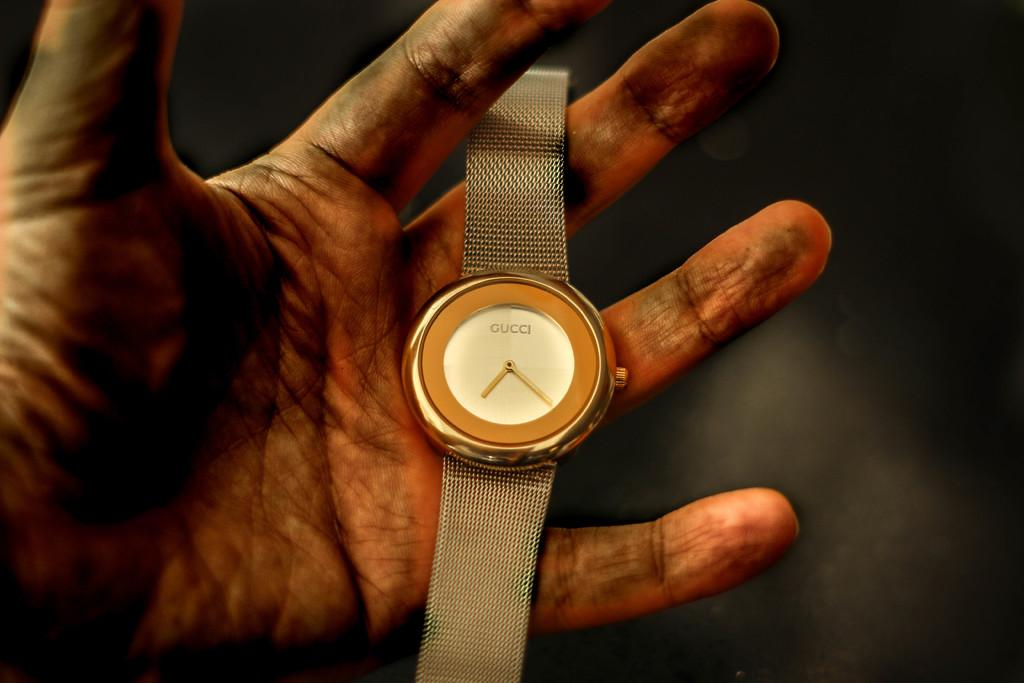Provide a one-sentence caption for the provided image. The Gucci watch is setting in a man's dirty hand. 